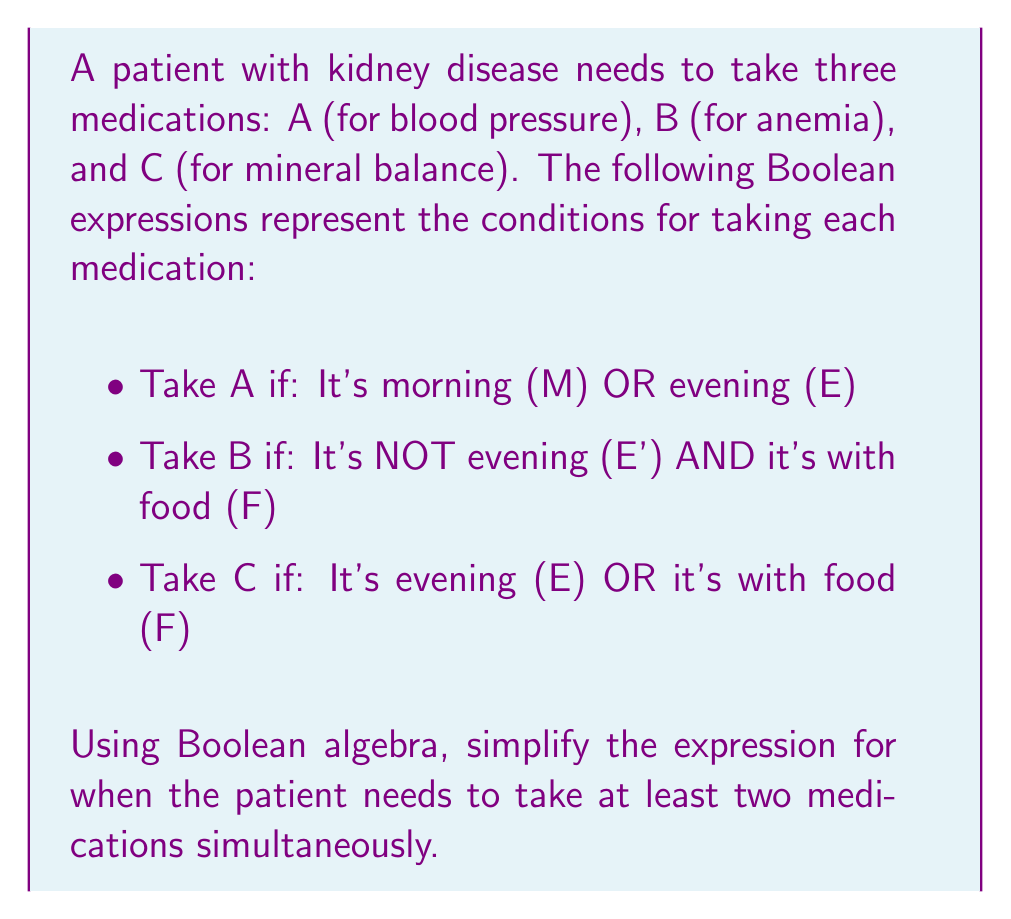Can you solve this math problem? Let's approach this step-by-step:

1) First, we need to write out the Boolean expressions for each medication:
   A = M + E
   B = E' · F
   C = E + F

2) We want to find when at least two medications are taken simultaneously. This can be represented as:
   (A · B) + (A · C) + (B · C)

3) Let's expand each term:
   (A · B) = (M + E) · (E' · F) = (M · E' · F) + (E · E' · F) = M · E' · F
   (A · C) = (M + E) · (E + F) = M · E + M · F + E · E + E · F = M · E + M · F + E
   (B · C) = (E' · F) · (E + F) = E' · F · E + E' · F · F = E' · F

4) Now our expression is:
   (M · E' · F) + (M · E + M · F + E) + (E' · F)

5) Simplify:
   M · E' · F + M · E + M · F + E + E' · F
   = M · E' · F + M · E + M · F + E + E' · F  (Combine like terms)
   = M · F + M · E + E + E' · F  (Absorb M · E' · F into M · F)

6) This is our simplified Boolean expression.
Answer: $M \cdot F + M \cdot E + E + E' \cdot F$ 